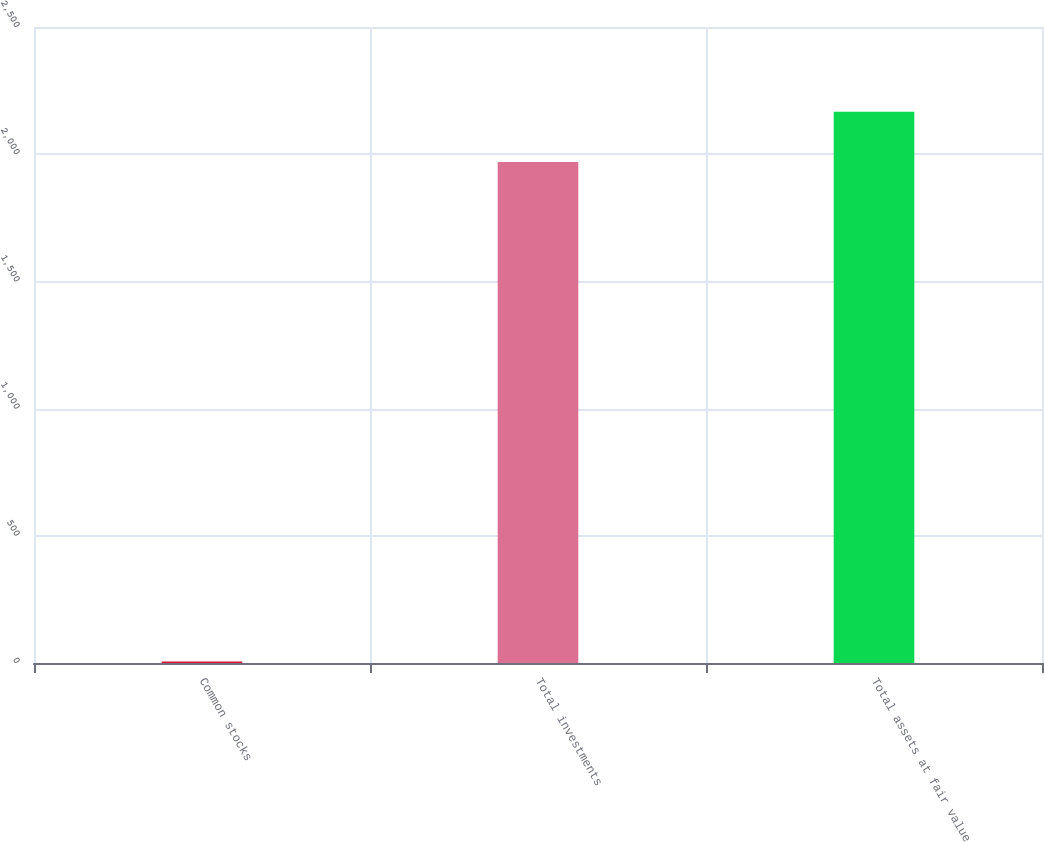<chart> <loc_0><loc_0><loc_500><loc_500><bar_chart><fcel>Common stocks<fcel>Total investments<fcel>Total assets at fair value<nl><fcel>6<fcel>1969<fcel>2166.4<nl></chart> 